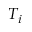Convert formula to latex. <formula><loc_0><loc_0><loc_500><loc_500>T _ { i }</formula> 